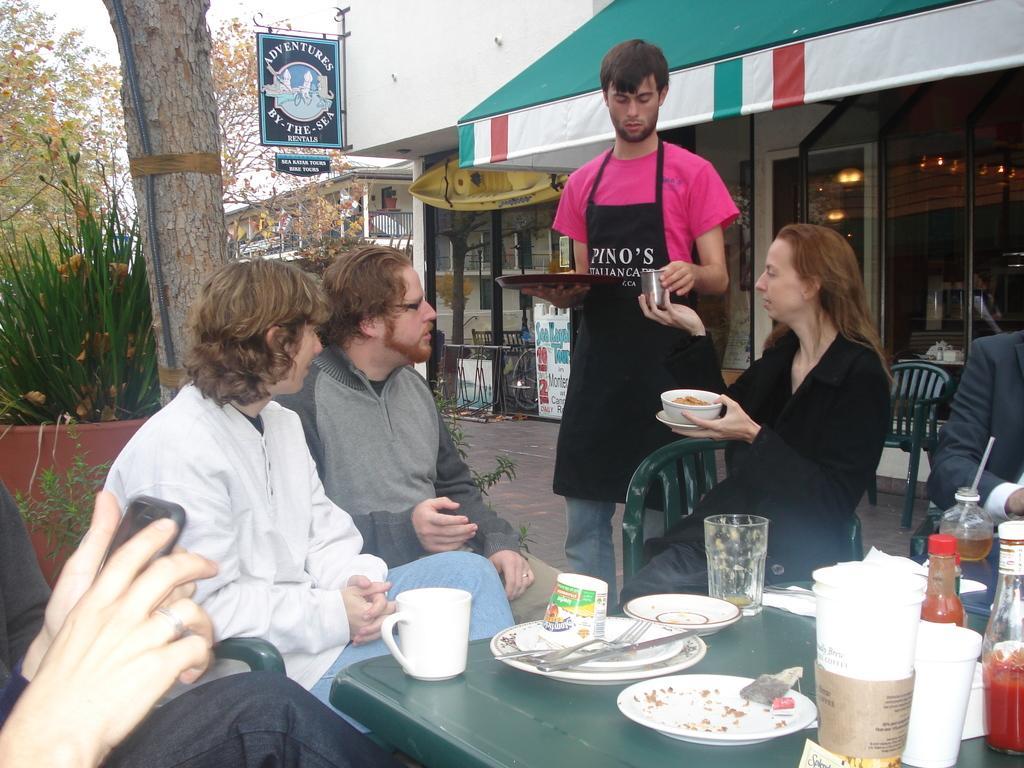Describe this image in one or two sentences. In this image, there are six persons. Out of which five are sitting on the chair in front of the table and one person is standing and holding a plate in his hand and a glass. In the left top of the image, there is a tree and plants visible. In the middle of the image, sky is visible which is white in color. In the right side of the image, there is a restaurant, beside that the building is visible. It looks as if the picture is taken outside in a sunny day. 